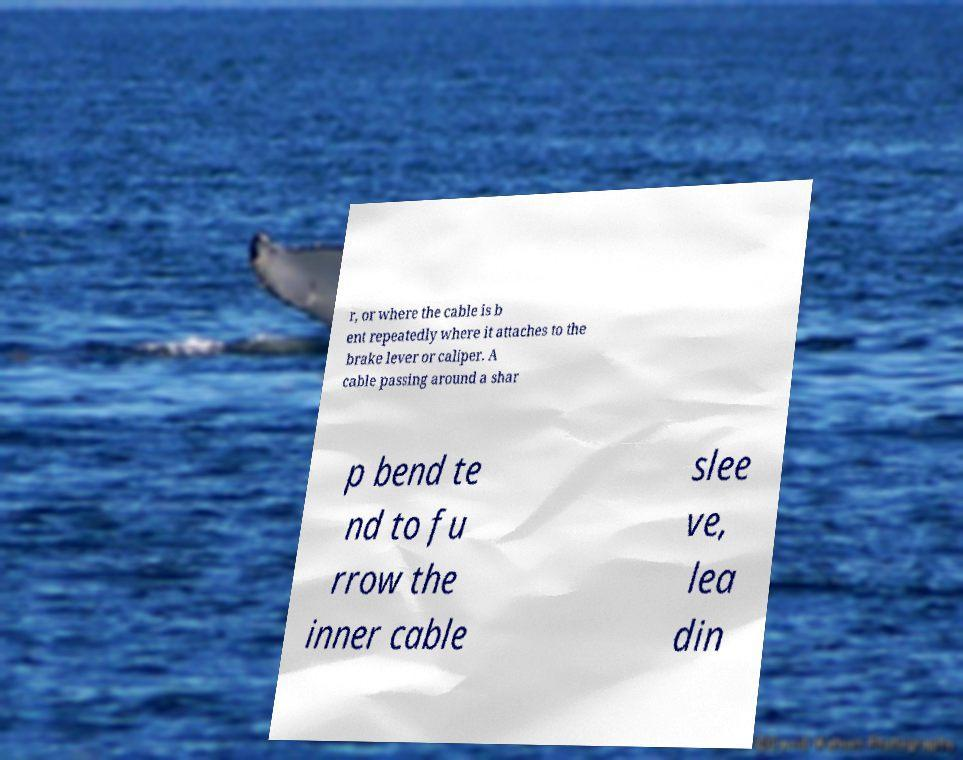For documentation purposes, I need the text within this image transcribed. Could you provide that? r, or where the cable is b ent repeatedly where it attaches to the brake lever or caliper. A cable passing around a shar p bend te nd to fu rrow the inner cable slee ve, lea din 